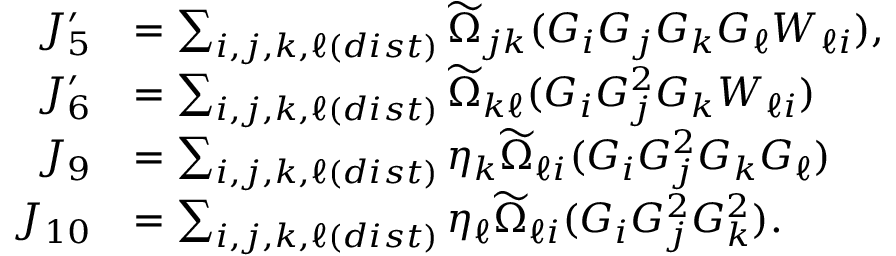Convert formula to latex. <formula><loc_0><loc_0><loc_500><loc_500>\begin{array} { r l } { J _ { 5 } ^ { \prime } } & { = \sum _ { i , j , k , \ell ( d i s t ) } \widetilde { \Omega } _ { j k } ( G _ { i } G _ { j } G _ { k } G _ { \ell } W _ { \ell i } ) , } \\ { J _ { 6 } ^ { \prime } } & { = \sum _ { i , j , k , \ell ( d i s t ) } \widetilde { \Omega } _ { k \ell } ( G _ { i } G _ { j } ^ { 2 } G _ { k } W _ { \ell i } ) } \\ { J _ { 9 } } & { = \sum _ { i , j , k , \ell ( d i s t ) } \eta _ { k } \widetilde { \Omega } _ { \ell i } ( G _ { i } G _ { j } ^ { 2 } G _ { k } G _ { \ell } ) } \\ { J _ { 1 0 } } & { = \sum _ { i , j , k , \ell ( d i s t ) } \eta _ { \ell } \widetilde { \Omega } _ { \ell i } ( G _ { i } G _ { j } ^ { 2 } G _ { k } ^ { 2 } ) . } \end{array}</formula> 